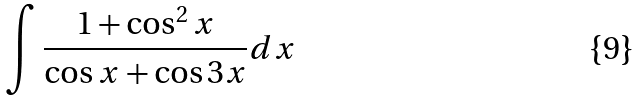<formula> <loc_0><loc_0><loc_500><loc_500>\int \frac { 1 + \cos ^ { 2 } x } { \cos x + \cos 3 x } d x</formula> 